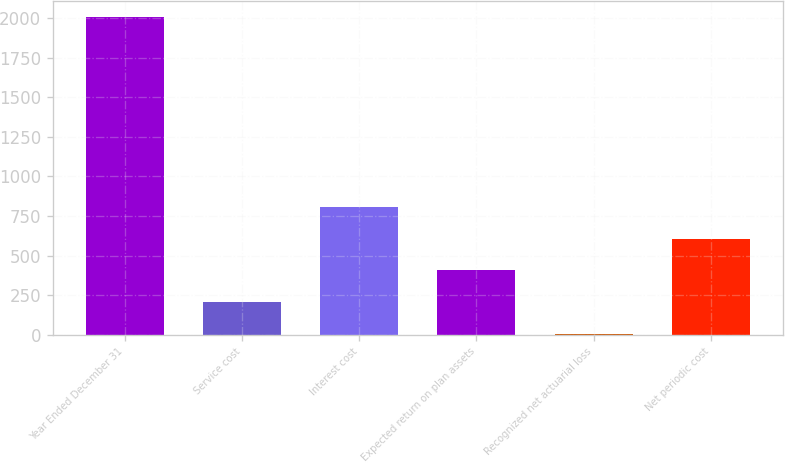Convert chart to OTSL. <chart><loc_0><loc_0><loc_500><loc_500><bar_chart><fcel>Year Ended December 31<fcel>Service cost<fcel>Interest cost<fcel>Expected return on plan assets<fcel>Recognized net actuarial loss<fcel>Net periodic cost<nl><fcel>2007<fcel>206.1<fcel>806.4<fcel>406.2<fcel>6<fcel>606.3<nl></chart> 